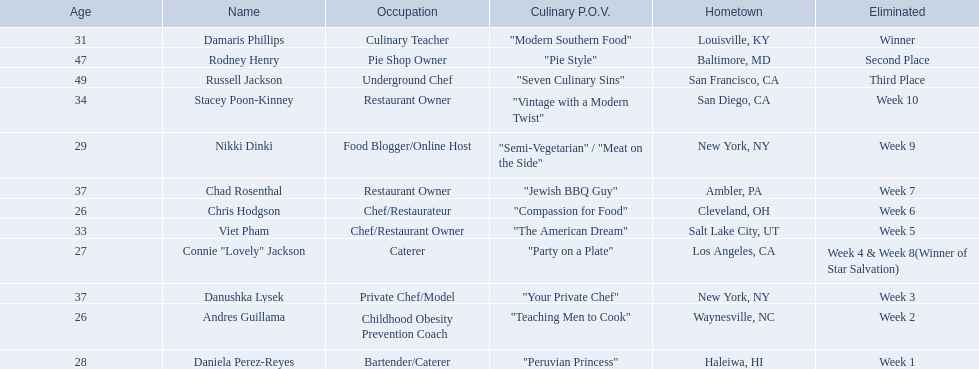Who are all of the people listed? Damaris Phillips, Rodney Henry, Russell Jackson, Stacey Poon-Kinney, Nikki Dinki, Chad Rosenthal, Chris Hodgson, Viet Pham, Connie "Lovely" Jackson, Danushka Lysek, Andres Guillama, Daniela Perez-Reyes. How old are they? 31, 47, 49, 34, 29, 37, 26, 33, 27, 37, 26, 28. Along with chris hodgson, which other person is 26 years old? Andres Guillama. 